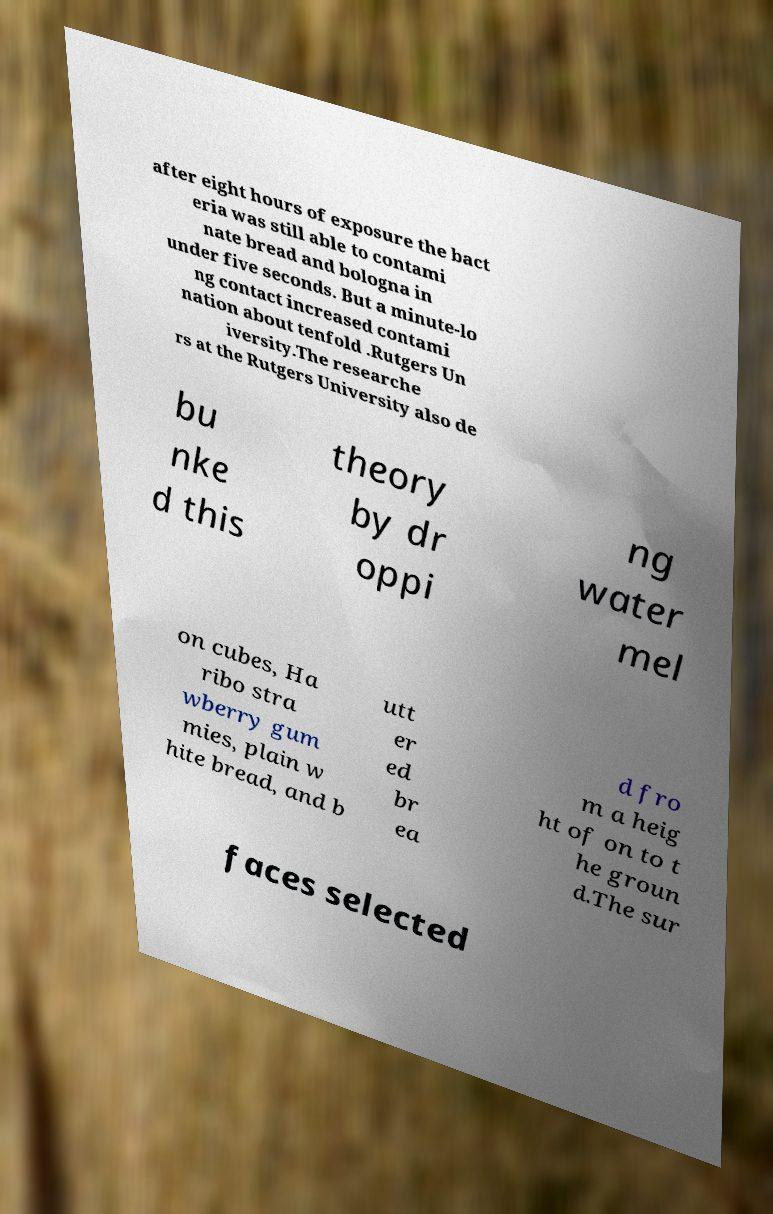Please read and relay the text visible in this image. What does it say? after eight hours of exposure the bact eria was still able to contami nate bread and bologna in under five seconds. But a minute-lo ng contact increased contami nation about tenfold .Rutgers Un iversity.The researche rs at the Rutgers University also de bu nke d this theory by dr oppi ng water mel on cubes, Ha ribo stra wberry gum mies, plain w hite bread, and b utt er ed br ea d fro m a heig ht of on to t he groun d.The sur faces selected 